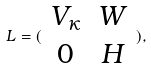<formula> <loc_0><loc_0><loc_500><loc_500>L = ( \begin{array} { c c } V _ { \kappa } & W \\ 0 & H \end{array} ) ,</formula> 